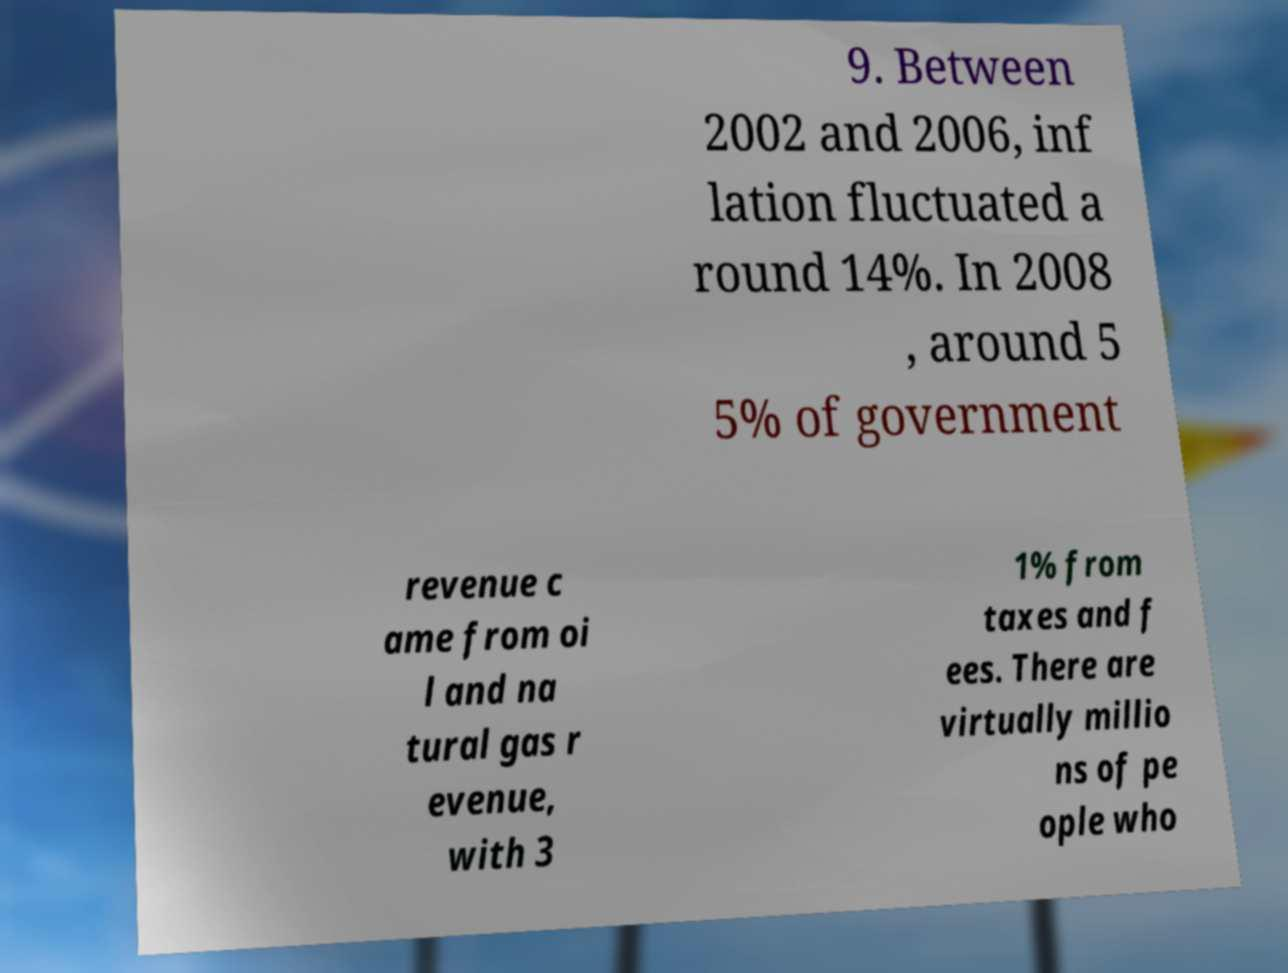Please identify and transcribe the text found in this image. 9. Between 2002 and 2006, inf lation fluctuated a round 14%. In 2008 , around 5 5% of government revenue c ame from oi l and na tural gas r evenue, with 3 1% from taxes and f ees. There are virtually millio ns of pe ople who 